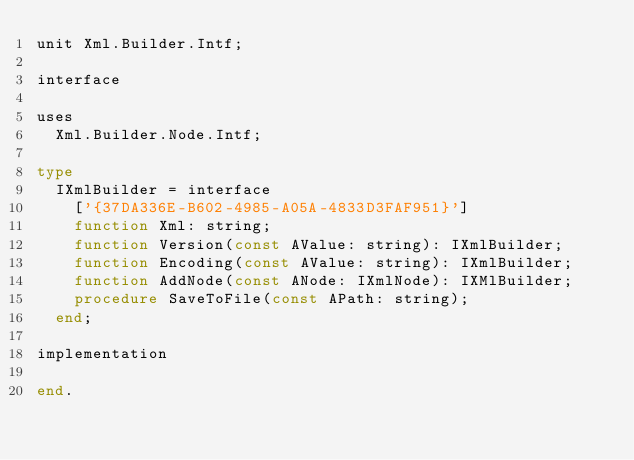<code> <loc_0><loc_0><loc_500><loc_500><_Pascal_>unit Xml.Builder.Intf;

interface

uses
  Xml.Builder.Node.Intf;

type
  IXmlBuilder = interface
    ['{37DA336E-B602-4985-A05A-4833D3FAF951}']
    function Xml: string;
    function Version(const AValue: string): IXmlBuilder;
    function Encoding(const AValue: string): IXmlBuilder;
    function AddNode(const ANode: IXmlNode): IXMlBuilder;
    procedure SaveToFile(const APath: string);
  end;

implementation

end.
</code> 